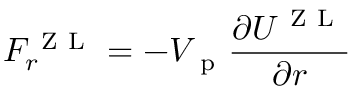<formula> <loc_0><loc_0><loc_500><loc_500>F _ { r } ^ { Z L } = - V _ { p } \frac { \partial U ^ { Z L } } { \partial r }</formula> 